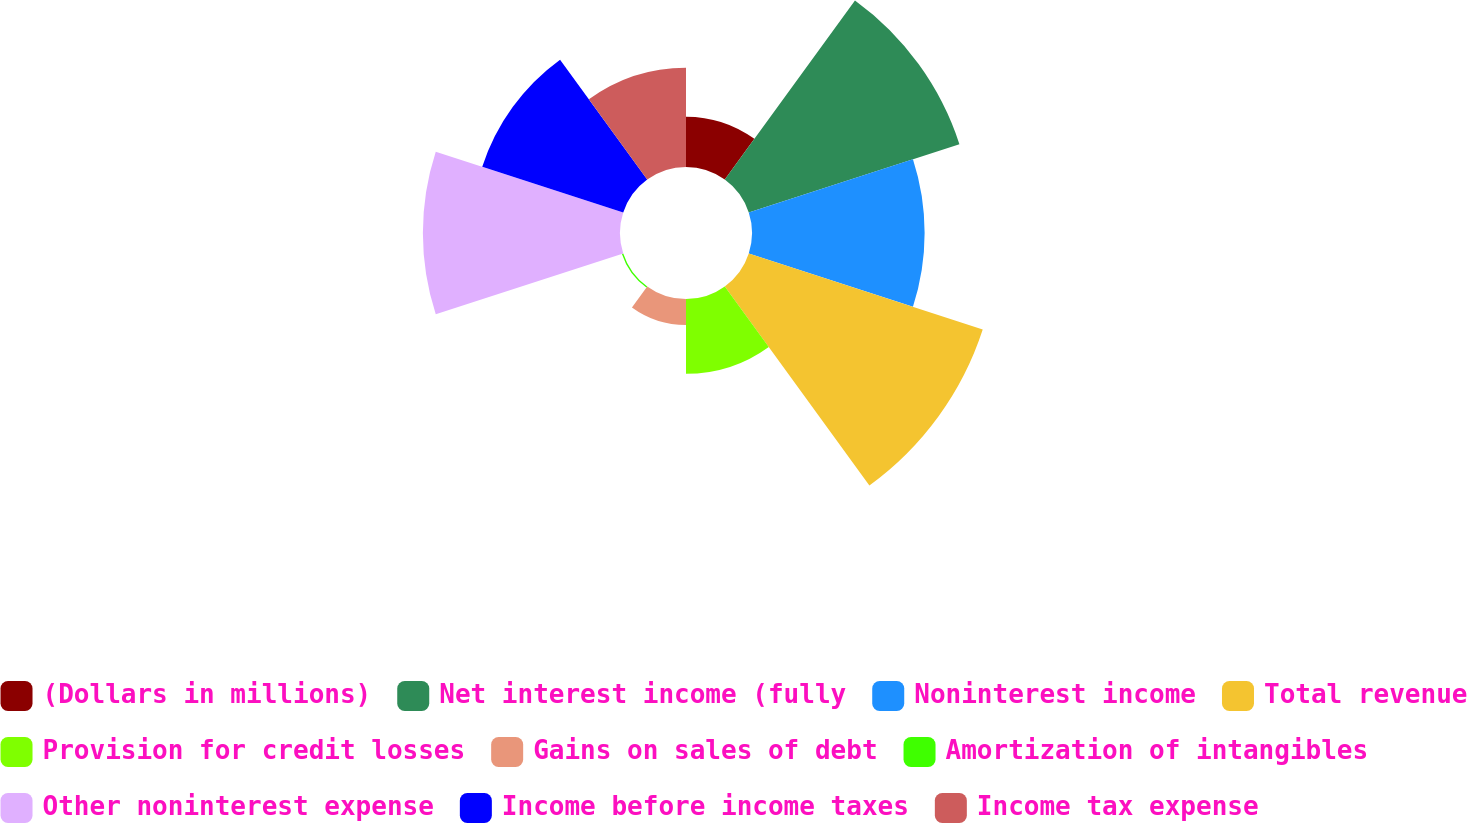Convert chart to OTSL. <chart><loc_0><loc_0><loc_500><loc_500><pie_chart><fcel>(Dollars in millions)<fcel>Net interest income (fully<fcel>Noninterest income<fcel>Total revenue<fcel>Provision for credit losses<fcel>Gains on sales of debt<fcel>Amortization of intangibles<fcel>Other noninterest expense<fcel>Income before income taxes<fcel>Income tax expense<nl><fcel>4.07%<fcel>17.9%<fcel>13.95%<fcel>19.88%<fcel>6.05%<fcel>2.1%<fcel>0.12%<fcel>15.93%<fcel>11.98%<fcel>8.02%<nl></chart> 